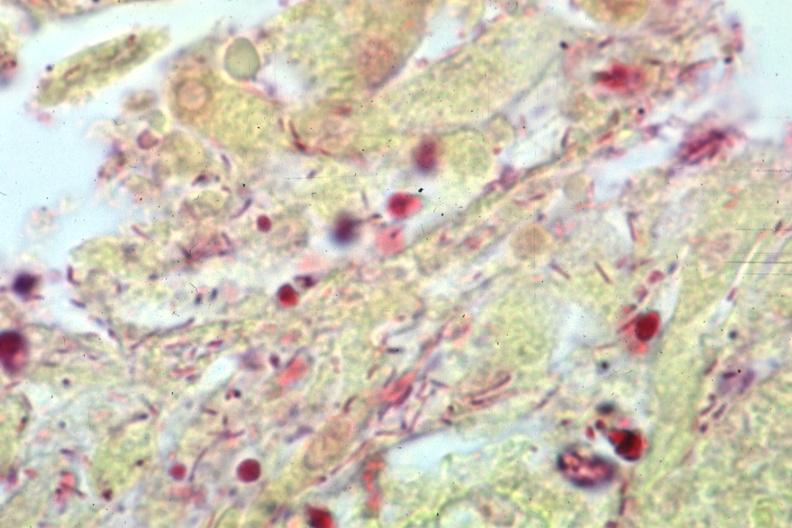s another fiber other frame present?
Answer the question using a single word or phrase. No 